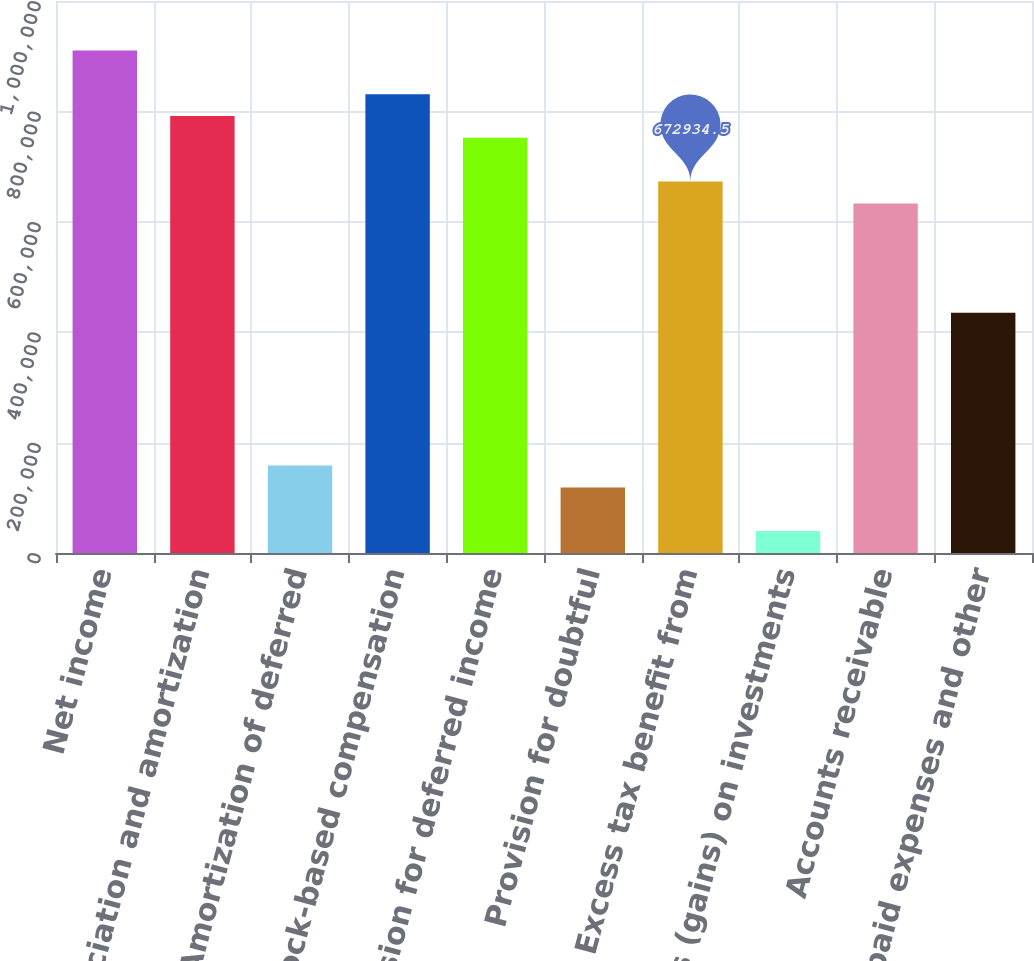Convert chart to OTSL. <chart><loc_0><loc_0><loc_500><loc_500><bar_chart><fcel>Net income<fcel>Depreciation and amortization<fcel>Amortization of deferred<fcel>Stock-based compensation<fcel>Provision for deferred income<fcel>Provision for doubtful<fcel>Excess tax benefit from<fcel>Losses (gains) on investments<fcel>Accounts receivable<fcel>Prepaid expenses and other<nl><fcel>910418<fcel>791676<fcel>158388<fcel>831256<fcel>752096<fcel>118808<fcel>672934<fcel>39646.5<fcel>633354<fcel>435452<nl></chart> 